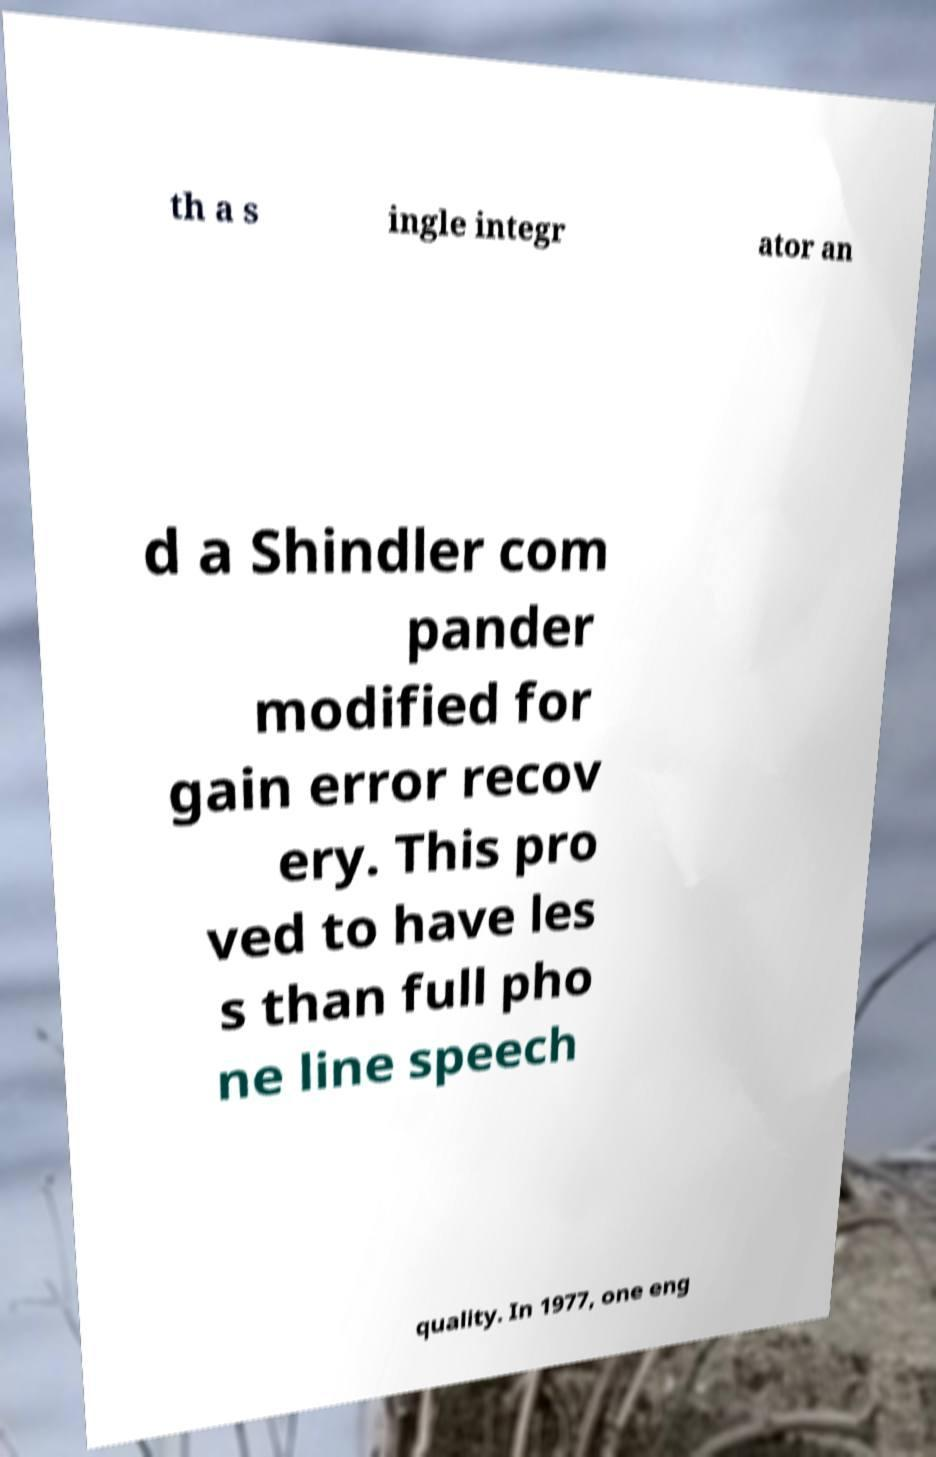Can you read and provide the text displayed in the image?This photo seems to have some interesting text. Can you extract and type it out for me? th a s ingle integr ator an d a Shindler com pander modified for gain error recov ery. This pro ved to have les s than full pho ne line speech quality. In 1977, one eng 